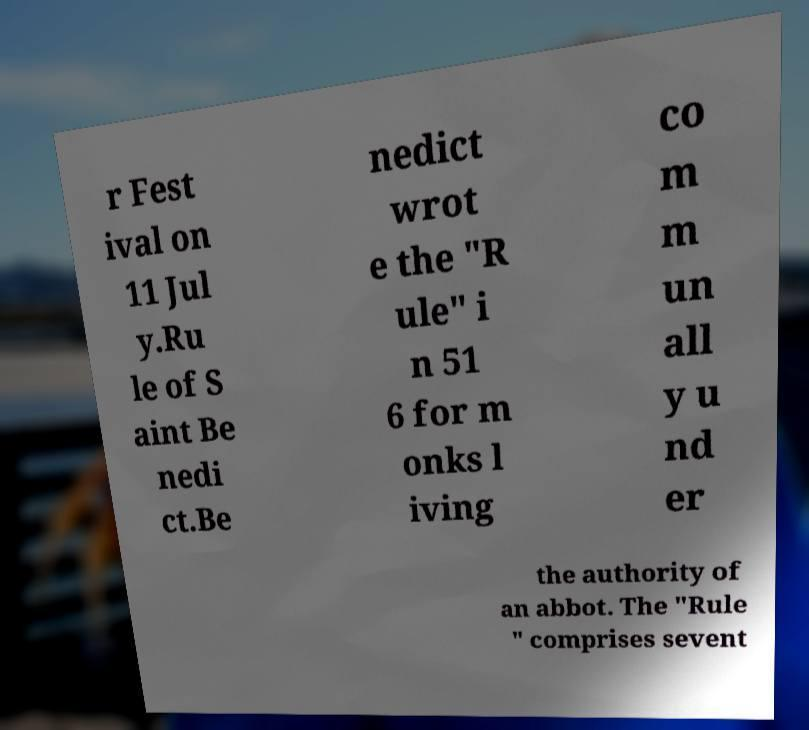Could you extract and type out the text from this image? r Fest ival on 11 Jul y.Ru le of S aint Be nedi ct.Be nedict wrot e the "R ule" i n 51 6 for m onks l iving co m m un all y u nd er the authority of an abbot. The "Rule " comprises sevent 